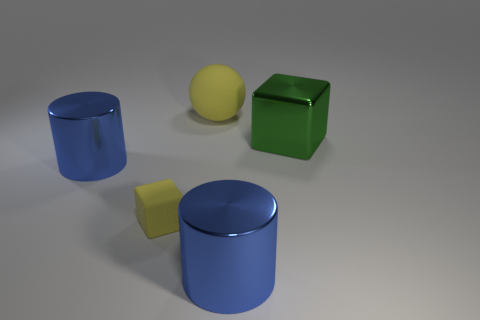Is there anything else that has the same material as the sphere? Yes, the two cylinders appear to have a similar glossy finish and reflective property as the sphere, indicating that they might be made of a material with similar characteristics, such as plastic or polished metal. 